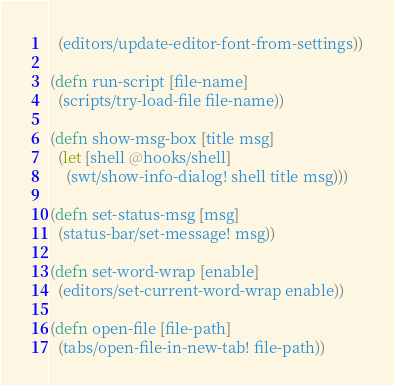Convert code to text. <code><loc_0><loc_0><loc_500><loc_500><_Clojure_>  (editors/update-editor-font-from-settings))

(defn run-script [file-name]
  (scripts/try-load-file file-name))

(defn show-msg-box [title msg]
  (let [shell @hooks/shell]
    (swt/show-info-dialog! shell title msg)))

(defn set-status-msg [msg]
  (status-bar/set-message! msg))

(defn set-word-wrap [enable]
  (editors/set-current-word-wrap enable))

(defn open-file [file-path]
  (tabs/open-file-in-new-tab! file-path))</code> 